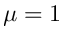Convert formula to latex. <formula><loc_0><loc_0><loc_500><loc_500>\mu = 1</formula> 